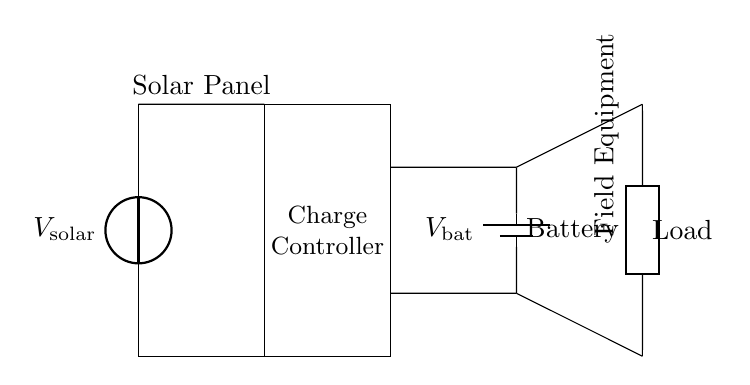What is the source of power in this circuit? The source of power is the solar panel, which converts solar energy into electrical energy.
Answer: solar panel What component regulates the voltage in this circuit? The charge controller is the component responsible for regulating the voltage and preventing overcharging of the battery.
Answer: charge controller What is the role of the battery in this circuit? The battery stores the electrical energy generated by the solar panel for later use by the load and ensures a stable power supply.
Answer: energy storage How are the solar panel and charge controller connected? The solar panel is connected to the charge controller through conductive lines that allow the electrical current to flow from the panel to the controller.
Answer: through short connections What type of load is powered by this circuit? The load is field research equipment, which implies that the circuit is used to power devices necessary for conducting field research.
Answer: field equipment What is likely the main purpose of the charge controller? The main purpose of the charge controller is to prevent overcharging of the battery and to ensure safe operation by controlling the flow of electricity.
Answer: prevent overcharging 